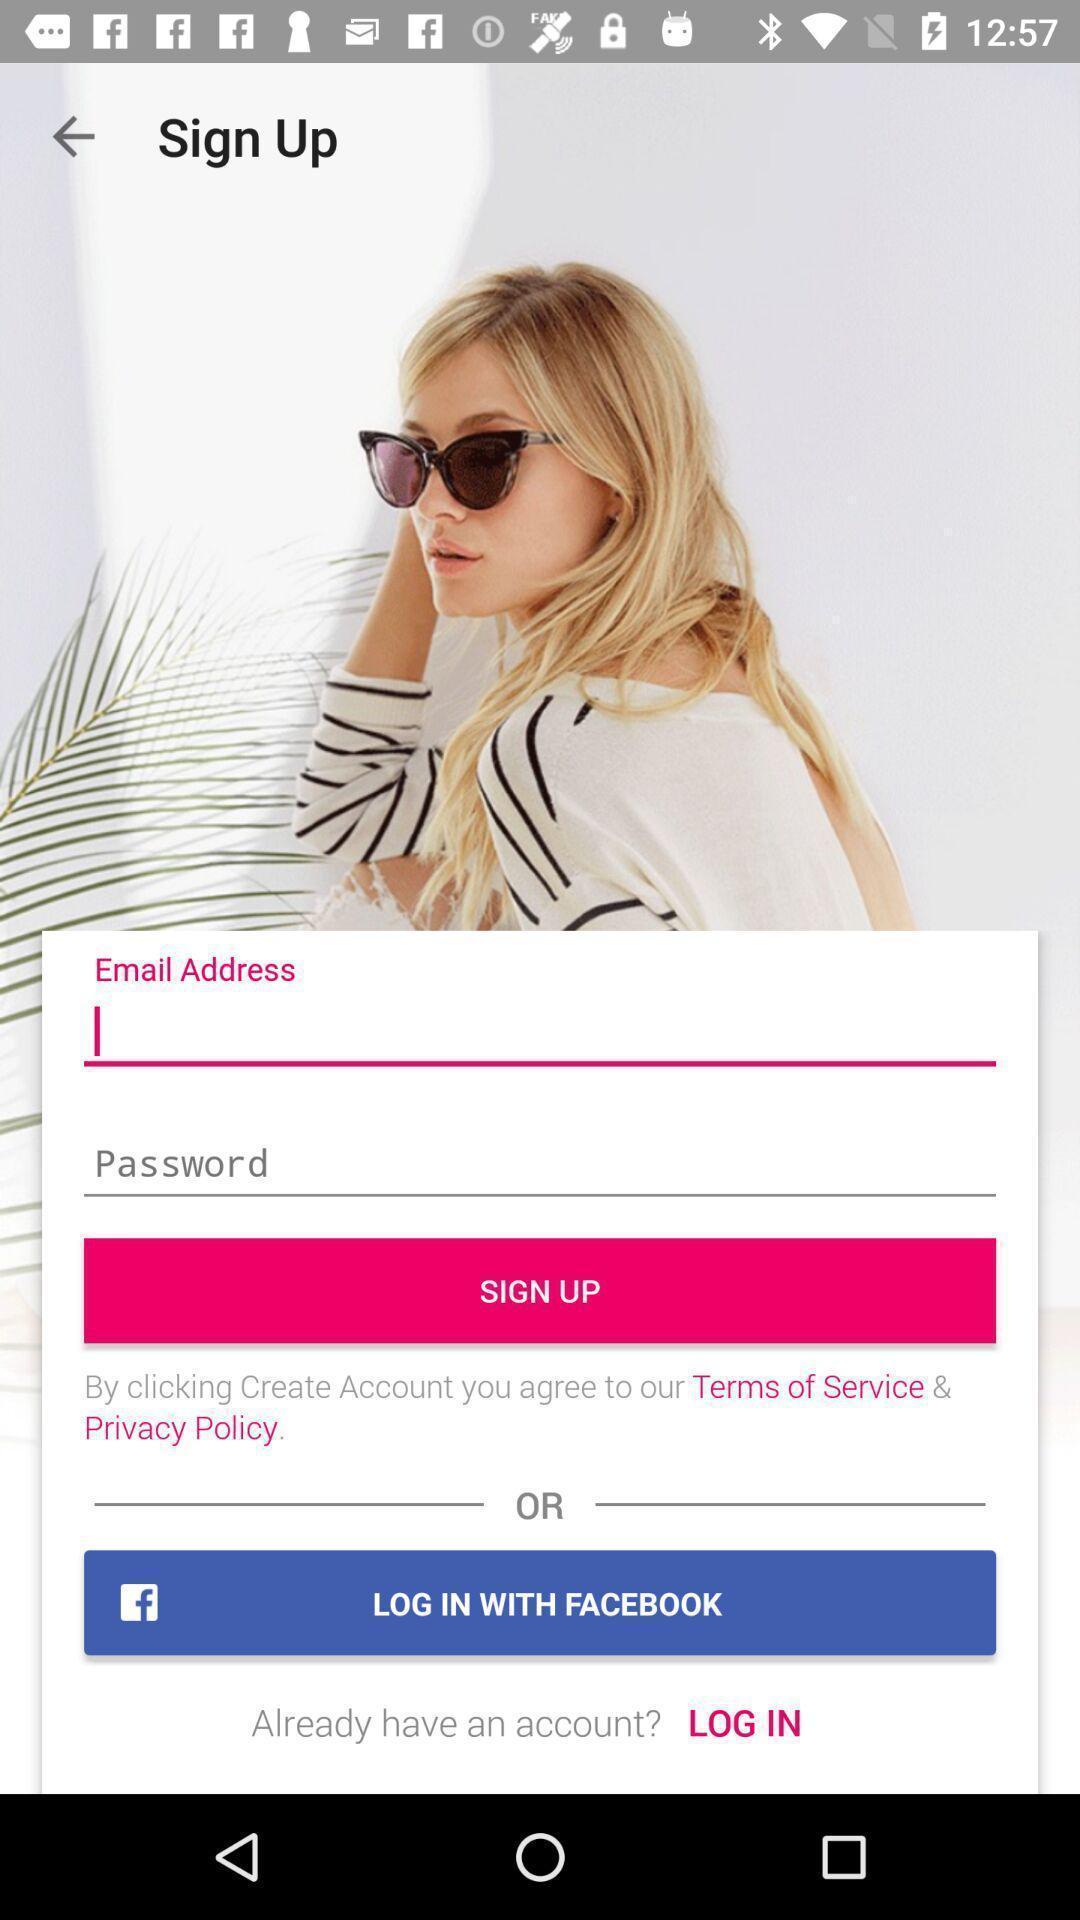Provide a description of this screenshot. Sign up page with text boxes to enter the credentials. 